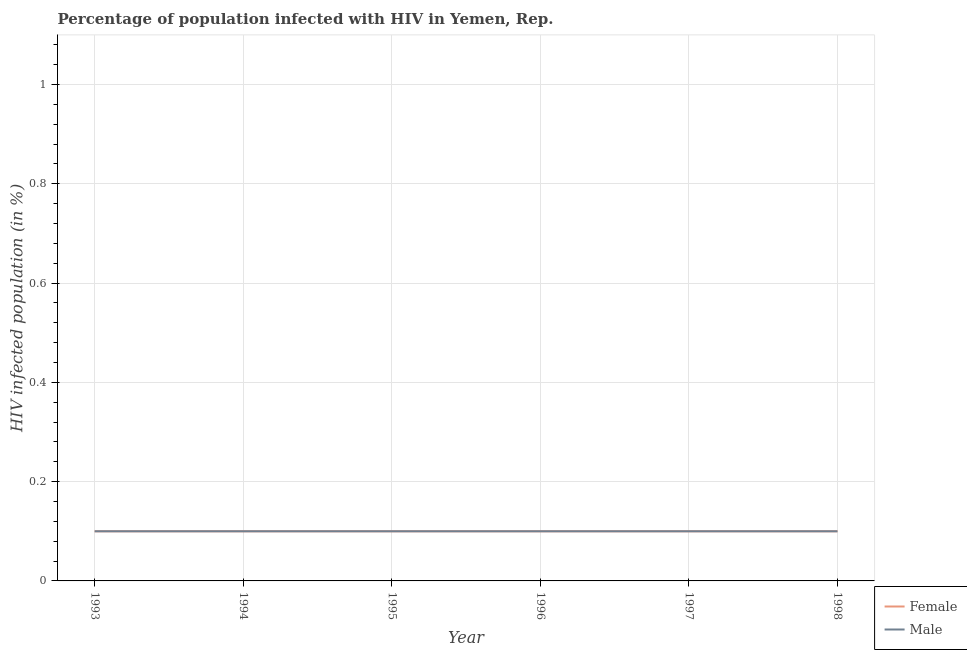Across all years, what is the maximum percentage of males who are infected with hiv?
Offer a terse response. 0.1. Across all years, what is the minimum percentage of males who are infected with hiv?
Offer a terse response. 0.1. In which year was the percentage of males who are infected with hiv maximum?
Provide a short and direct response. 1993. In which year was the percentage of males who are infected with hiv minimum?
Keep it short and to the point. 1993. What is the difference between the percentage of females who are infected with hiv in 1993 and the percentage of males who are infected with hiv in 1996?
Offer a terse response. 0. What is the average percentage of males who are infected with hiv per year?
Ensure brevity in your answer.  0.1. In the year 1996, what is the difference between the percentage of males who are infected with hiv and percentage of females who are infected with hiv?
Offer a very short reply. 0. What is the ratio of the percentage of males who are infected with hiv in 1995 to that in 1996?
Keep it short and to the point. 1. Is the percentage of males who are infected with hiv in 1995 less than that in 1996?
Provide a short and direct response. No. What is the difference between the highest and the lowest percentage of males who are infected with hiv?
Provide a short and direct response. 0. Does the percentage of males who are infected with hiv monotonically increase over the years?
Offer a very short reply. No. Is the percentage of females who are infected with hiv strictly greater than the percentage of males who are infected with hiv over the years?
Offer a terse response. No. Is the percentage of males who are infected with hiv strictly less than the percentage of females who are infected with hiv over the years?
Offer a terse response. No. How many lines are there?
Offer a very short reply. 2. Does the graph contain grids?
Your response must be concise. Yes. What is the title of the graph?
Your answer should be very brief. Percentage of population infected with HIV in Yemen, Rep. What is the label or title of the Y-axis?
Give a very brief answer. HIV infected population (in %). What is the HIV infected population (in %) of Female in 1993?
Keep it short and to the point. 0.1. What is the HIV infected population (in %) of Male in 1994?
Ensure brevity in your answer.  0.1. What is the HIV infected population (in %) in Female in 1996?
Provide a short and direct response. 0.1. What is the HIV infected population (in %) of Male in 1996?
Your response must be concise. 0.1. What is the HIV infected population (in %) in Male in 1997?
Your answer should be very brief. 0.1. What is the HIV infected population (in %) of Male in 1998?
Provide a succinct answer. 0.1. Across all years, what is the maximum HIV infected population (in %) in Male?
Your answer should be very brief. 0.1. Across all years, what is the minimum HIV infected population (in %) of Female?
Your answer should be very brief. 0.1. What is the difference between the HIV infected population (in %) in Male in 1993 and that in 1994?
Your answer should be very brief. 0. What is the difference between the HIV infected population (in %) of Female in 1993 and that in 1995?
Your response must be concise. 0. What is the difference between the HIV infected population (in %) of Male in 1993 and that in 1996?
Make the answer very short. 0. What is the difference between the HIV infected population (in %) of Female in 1993 and that in 1998?
Keep it short and to the point. 0. What is the difference between the HIV infected population (in %) of Female in 1994 and that in 1995?
Your answer should be compact. 0. What is the difference between the HIV infected population (in %) of Male in 1994 and that in 1995?
Give a very brief answer. 0. What is the difference between the HIV infected population (in %) in Female in 1994 and that in 1996?
Provide a short and direct response. 0. What is the difference between the HIV infected population (in %) in Female in 1994 and that in 1998?
Give a very brief answer. 0. What is the difference between the HIV infected population (in %) of Male in 1995 and that in 1996?
Keep it short and to the point. 0. What is the difference between the HIV infected population (in %) of Female in 1995 and that in 1997?
Provide a short and direct response. 0. What is the difference between the HIV infected population (in %) of Female in 1995 and that in 1998?
Provide a succinct answer. 0. What is the difference between the HIV infected population (in %) of Female in 1996 and that in 1997?
Give a very brief answer. 0. What is the difference between the HIV infected population (in %) in Male in 1996 and that in 1997?
Give a very brief answer. 0. What is the difference between the HIV infected population (in %) in Female in 1996 and that in 1998?
Your answer should be compact. 0. What is the difference between the HIV infected population (in %) of Female in 1993 and the HIV infected population (in %) of Male in 1994?
Ensure brevity in your answer.  0. What is the difference between the HIV infected population (in %) in Female in 1993 and the HIV infected population (in %) in Male in 1995?
Your response must be concise. 0. What is the difference between the HIV infected population (in %) of Female in 1993 and the HIV infected population (in %) of Male in 1996?
Your answer should be compact. 0. What is the difference between the HIV infected population (in %) of Female in 1993 and the HIV infected population (in %) of Male in 1998?
Your response must be concise. 0. What is the difference between the HIV infected population (in %) in Female in 1994 and the HIV infected population (in %) in Male in 1996?
Make the answer very short. 0. What is the difference between the HIV infected population (in %) in Female in 1995 and the HIV infected population (in %) in Male in 1997?
Make the answer very short. 0. What is the average HIV infected population (in %) of Female per year?
Keep it short and to the point. 0.1. What is the average HIV infected population (in %) of Male per year?
Offer a very short reply. 0.1. In the year 1993, what is the difference between the HIV infected population (in %) of Female and HIV infected population (in %) of Male?
Your answer should be very brief. 0. In the year 1994, what is the difference between the HIV infected population (in %) of Female and HIV infected population (in %) of Male?
Offer a terse response. 0. In the year 1998, what is the difference between the HIV infected population (in %) of Female and HIV infected population (in %) of Male?
Provide a succinct answer. 0. What is the ratio of the HIV infected population (in %) of Male in 1993 to that in 1995?
Your answer should be very brief. 1. What is the ratio of the HIV infected population (in %) in Male in 1994 to that in 1995?
Offer a very short reply. 1. What is the ratio of the HIV infected population (in %) of Female in 1994 to that in 1997?
Ensure brevity in your answer.  1. What is the ratio of the HIV infected population (in %) in Female in 1995 to that in 1997?
Your answer should be compact. 1. What is the ratio of the HIV infected population (in %) in Male in 1995 to that in 1998?
Give a very brief answer. 1. What is the ratio of the HIV infected population (in %) of Female in 1996 to that in 1997?
Your answer should be compact. 1. What is the ratio of the HIV infected population (in %) in Male in 1996 to that in 1997?
Ensure brevity in your answer.  1. What is the ratio of the HIV infected population (in %) of Female in 1996 to that in 1998?
Give a very brief answer. 1. What is the ratio of the HIV infected population (in %) in Male in 1996 to that in 1998?
Give a very brief answer. 1. What is the ratio of the HIV infected population (in %) of Male in 1997 to that in 1998?
Make the answer very short. 1. What is the difference between the highest and the second highest HIV infected population (in %) in Female?
Give a very brief answer. 0. What is the difference between the highest and the lowest HIV infected population (in %) of Male?
Give a very brief answer. 0. 